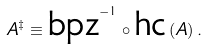<formula> <loc_0><loc_0><loc_500><loc_500>A ^ { \ddagger } \equiv \text {bpz} ^ { - 1 } \circ \text {hc} \, ( A ) \, .</formula> 